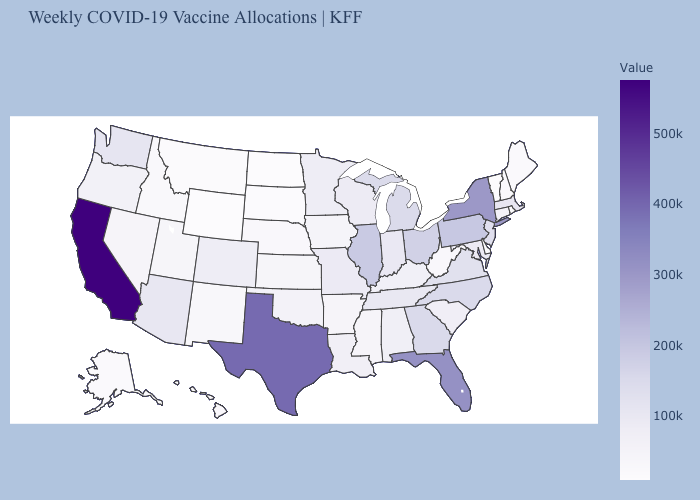Does Wyoming have the lowest value in the USA?
Concise answer only. Yes. Which states have the highest value in the USA?
Concise answer only. California. Is the legend a continuous bar?
Answer briefly. Yes. Is the legend a continuous bar?
Quick response, please. Yes. Does New Hampshire have the lowest value in the Northeast?
Give a very brief answer. No. Which states hav the highest value in the Northeast?
Concise answer only. New York. Does the map have missing data?
Be succinct. No. Among the states that border Massachusetts , which have the lowest value?
Give a very brief answer. Vermont. 